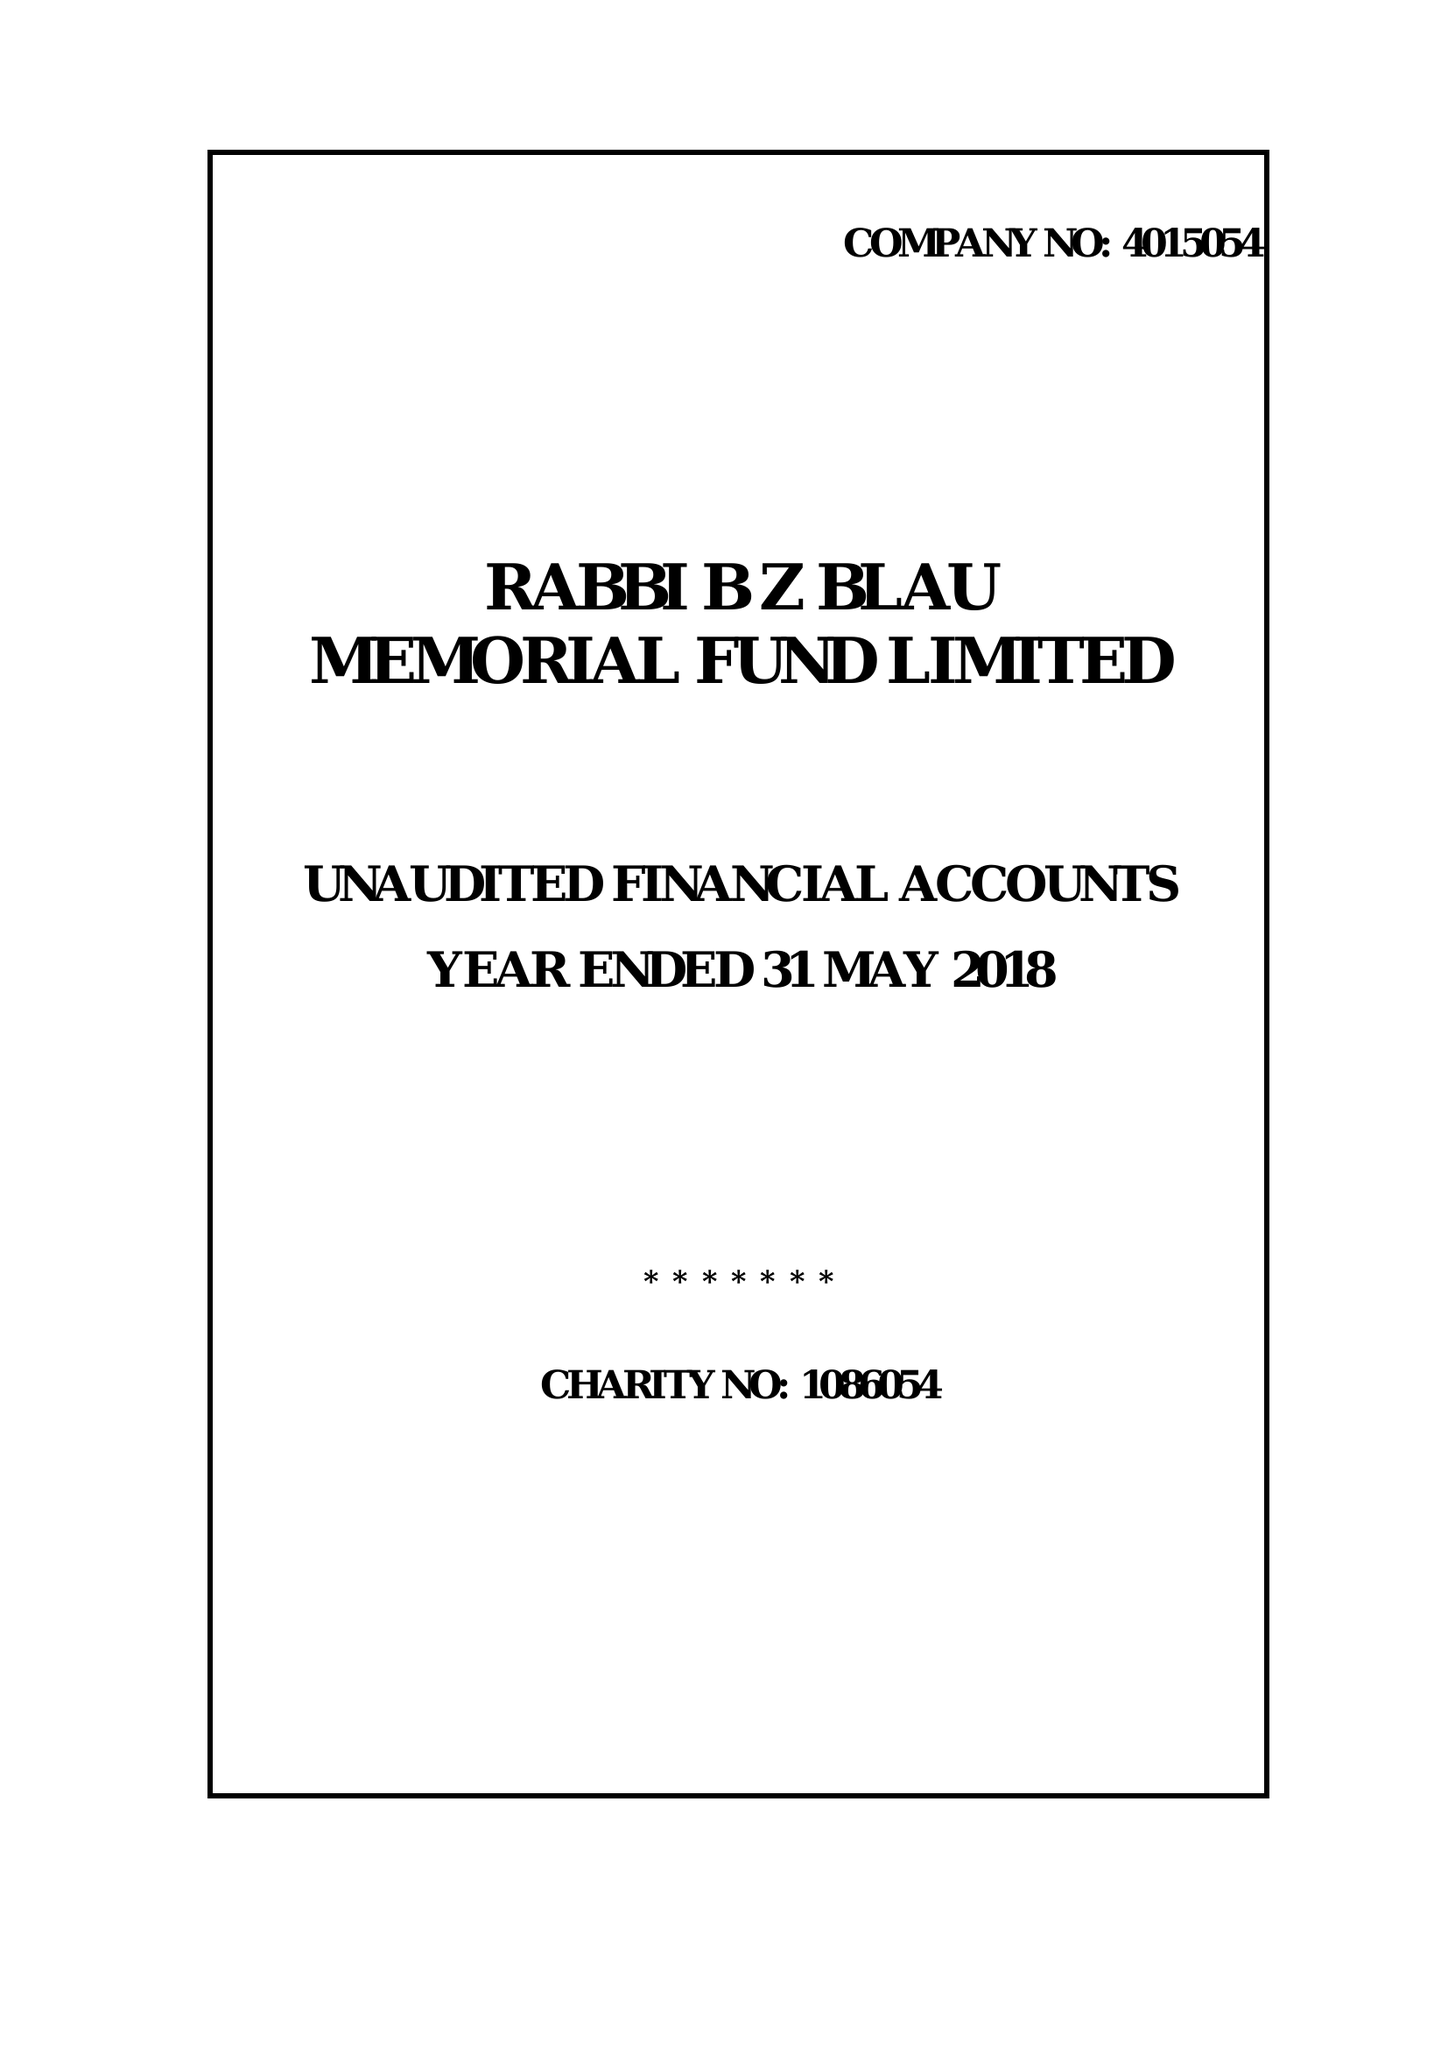What is the value for the report_date?
Answer the question using a single word or phrase. 2018-05-31 